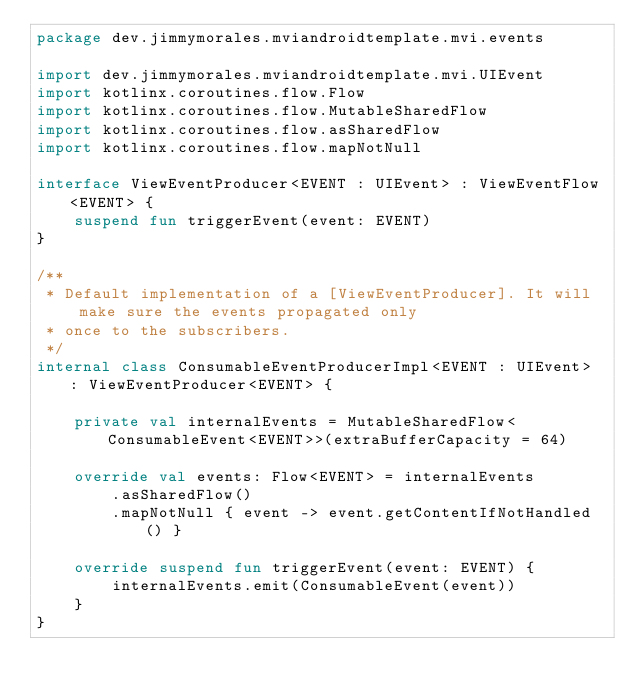Convert code to text. <code><loc_0><loc_0><loc_500><loc_500><_Kotlin_>package dev.jimmymorales.mviandroidtemplate.mvi.events

import dev.jimmymorales.mviandroidtemplate.mvi.UIEvent
import kotlinx.coroutines.flow.Flow
import kotlinx.coroutines.flow.MutableSharedFlow
import kotlinx.coroutines.flow.asSharedFlow
import kotlinx.coroutines.flow.mapNotNull

interface ViewEventProducer<EVENT : UIEvent> : ViewEventFlow<EVENT> {
    suspend fun triggerEvent(event: EVENT)
}

/**
 * Default implementation of a [ViewEventProducer]. It will make sure the events propagated only
 * once to the subscribers.
 */
internal class ConsumableEventProducerImpl<EVENT : UIEvent> : ViewEventProducer<EVENT> {

    private val internalEvents = MutableSharedFlow<ConsumableEvent<EVENT>>(extraBufferCapacity = 64)

    override val events: Flow<EVENT> = internalEvents
        .asSharedFlow()
        .mapNotNull { event -> event.getContentIfNotHandled() }

    override suspend fun triggerEvent(event: EVENT) {
        internalEvents.emit(ConsumableEvent(event))
    }
}
</code> 